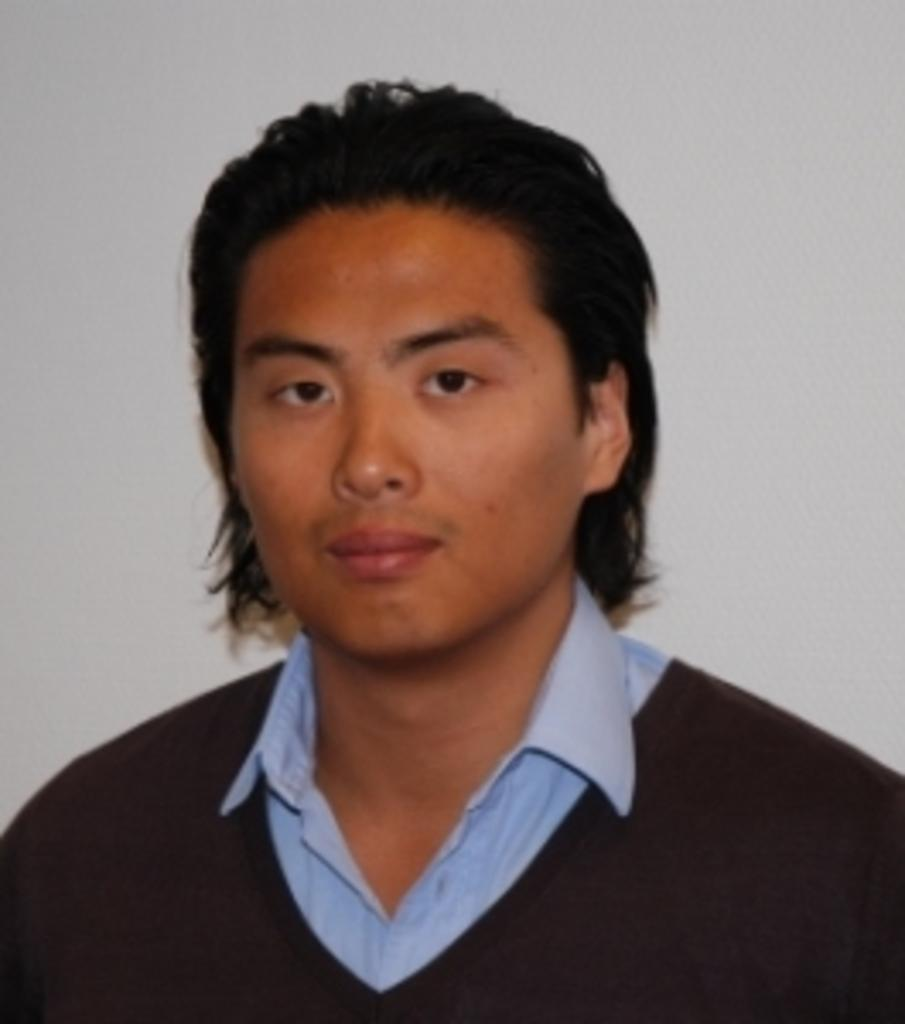What is the main subject of the image? There is a person in the center of the image. Can you describe the background of the image? There is a wall in the background of the image. What type of linen can be seen blowing in the ocean breeze in the image? There is no linen or ocean present in the image; it features a person and a wall. 